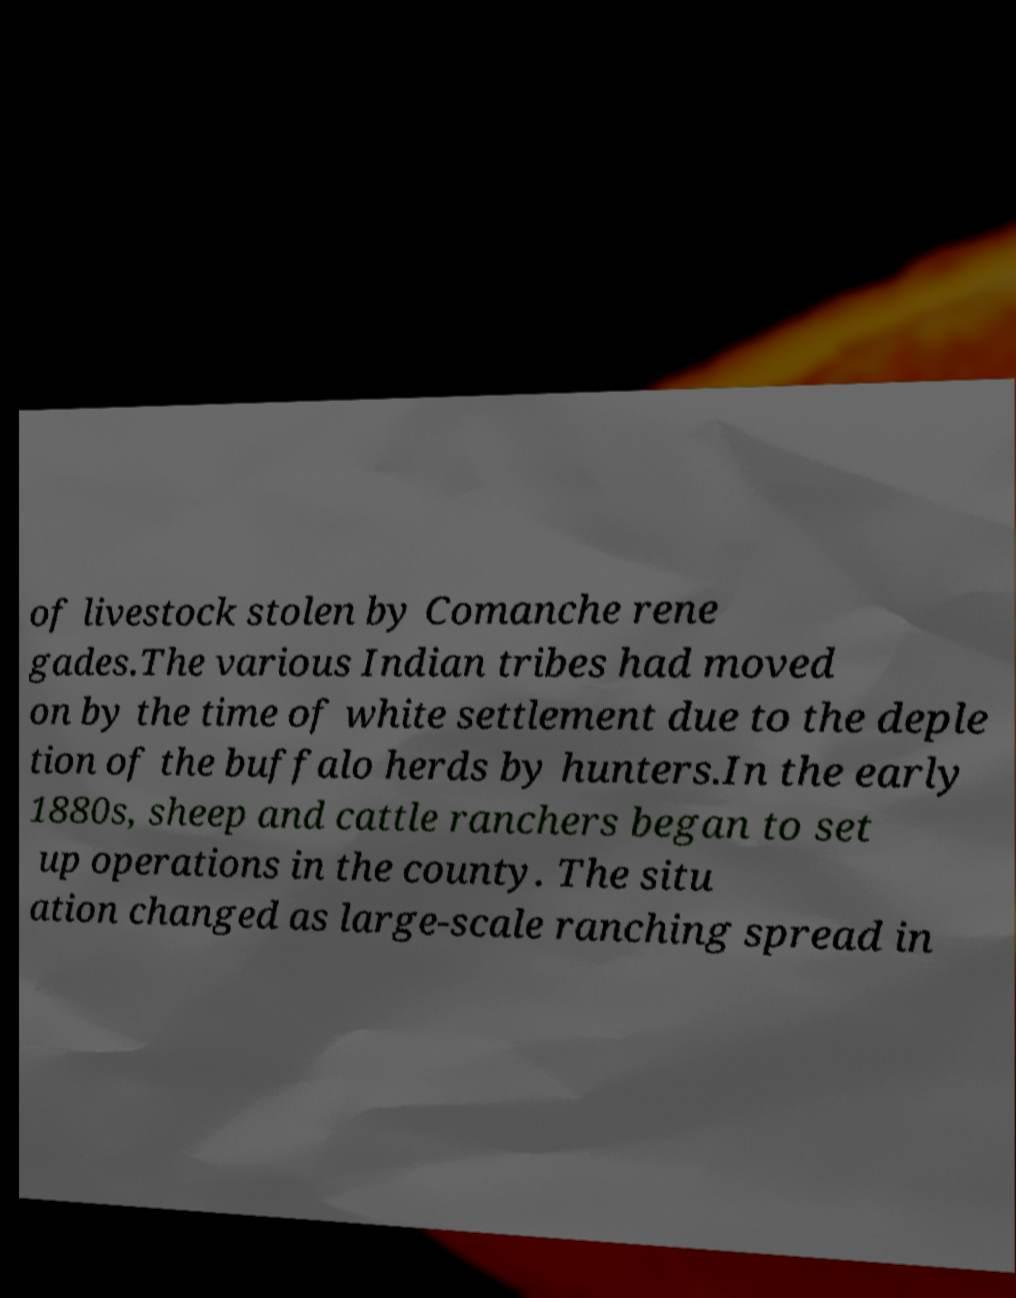Could you assist in decoding the text presented in this image and type it out clearly? of livestock stolen by Comanche rene gades.The various Indian tribes had moved on by the time of white settlement due to the deple tion of the buffalo herds by hunters.In the early 1880s, sheep and cattle ranchers began to set up operations in the county. The situ ation changed as large-scale ranching spread in 